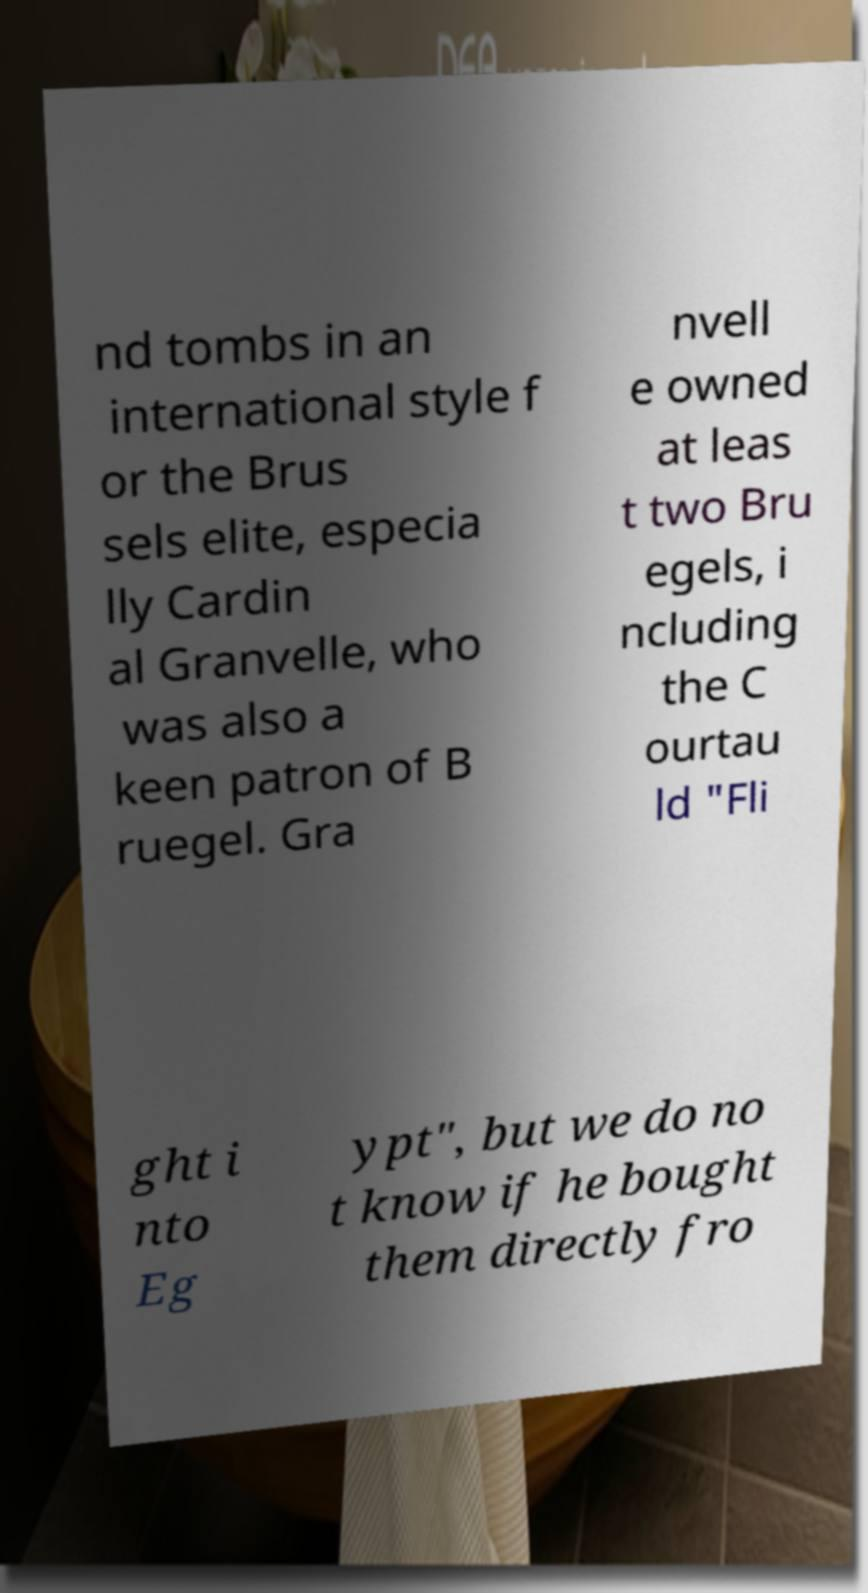There's text embedded in this image that I need extracted. Can you transcribe it verbatim? nd tombs in an international style f or the Brus sels elite, especia lly Cardin al Granvelle, who was also a keen patron of B ruegel. Gra nvell e owned at leas t two Bru egels, i ncluding the C ourtau ld "Fli ght i nto Eg ypt", but we do no t know if he bought them directly fro 